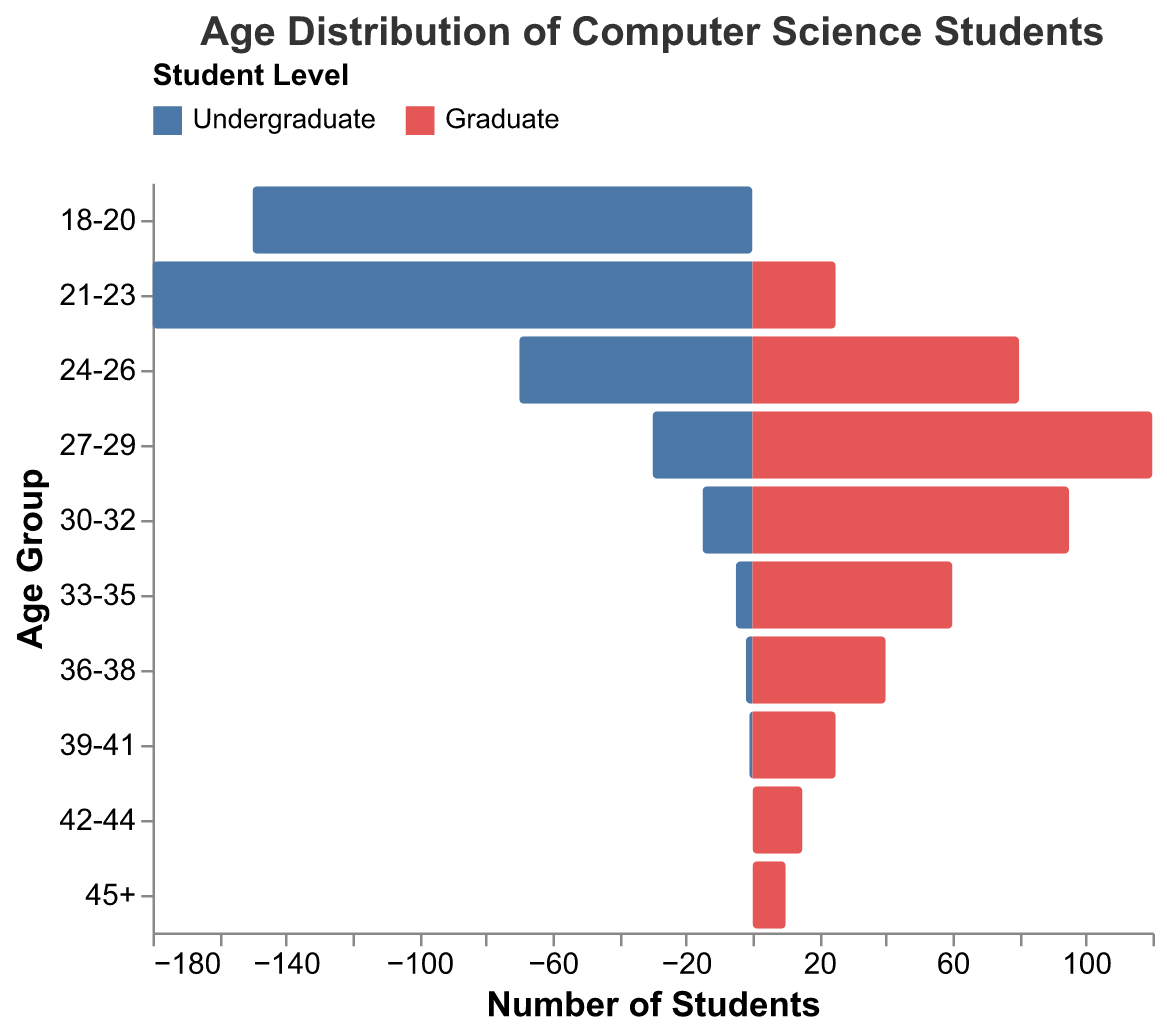What is the age distribution of undergraduate students? The age distribution of undergraduate students can be easily obtained by referring to the negative values on the bar plot, as undergraduate values are negatively signed. They appear in the 18-20, 21-23, 24-26, 27-29, 30-32, 33-35, 36-38, 39-41 age groups.
Answer: 18-20, 21-23, 24-26, 27-29, 30-32, 33-35, 36-38, 39-41 Which age group has the highest number of graduate students? By comparing the bar lengths on the positive side, it's evident that the 27-29 age group has the longest positive bar, representing the highest number of graduate students.
Answer: 27-29 What is the combined number of students (both undergraduate and graduate) in the 24-26 age group? Add the number of undergraduate students (70) and graduate students (80) in the 24-26 age category. 70 + 80 = 150.
Answer: 150 How many more undergraduate students are there than graduate students in the 21-23 age group? Subtract the number of graduate students (25) from the number of undergraduate students (180) in the 21-23 age group. 180 - 25 = 155.
Answer: 155 Which age group shows the closest number of undergraduate and graduate students? By visual comparison of the bar lengths, the 24-26 age group has undergraduate (70) and graduate (80) students, where the difference is the smallest (80 - 70 = 10).
Answer: 24-26 What is the average age group for graduate students? (Hint: You may need to consider the midpoint value for each range for a rough estimate) Calculate the midpoints for each range: [(19+22+25+28+31+34+37+40+43+45)/10], weighted by the number of students: [(18-20)*0 + (21-23)*25 + (24-26)*80 + (27-29)*120 + (30-32)*95 + (33-35)*60 + (36-38)*40 + (39-41)*25 + (42-44)*15 + (45+)*10] resulting in a rough weighted average age group.
Answer: 27-29 (approx) Is there any age group with no undergraduate students? By observing the negative bars, the age groups 42-44 and 45+ have no negative bars, indicating zero undergraduate students.
Answer: Yes, 42-44 and 45+ In which age group do the graduate students first outnumber the undergraduate students? Compare from the lowest age group up. The crossover point occurs in the 24-26 age group, where there are more graduate students (80) than undergraduates (70).
Answer: 24-26 What is the most common age group among undergraduate students? Find the longest negative bar which corresponds to the undergraduate students. The age group 21-23 has the longest negative bar with 180 students.
Answer: 21-23 